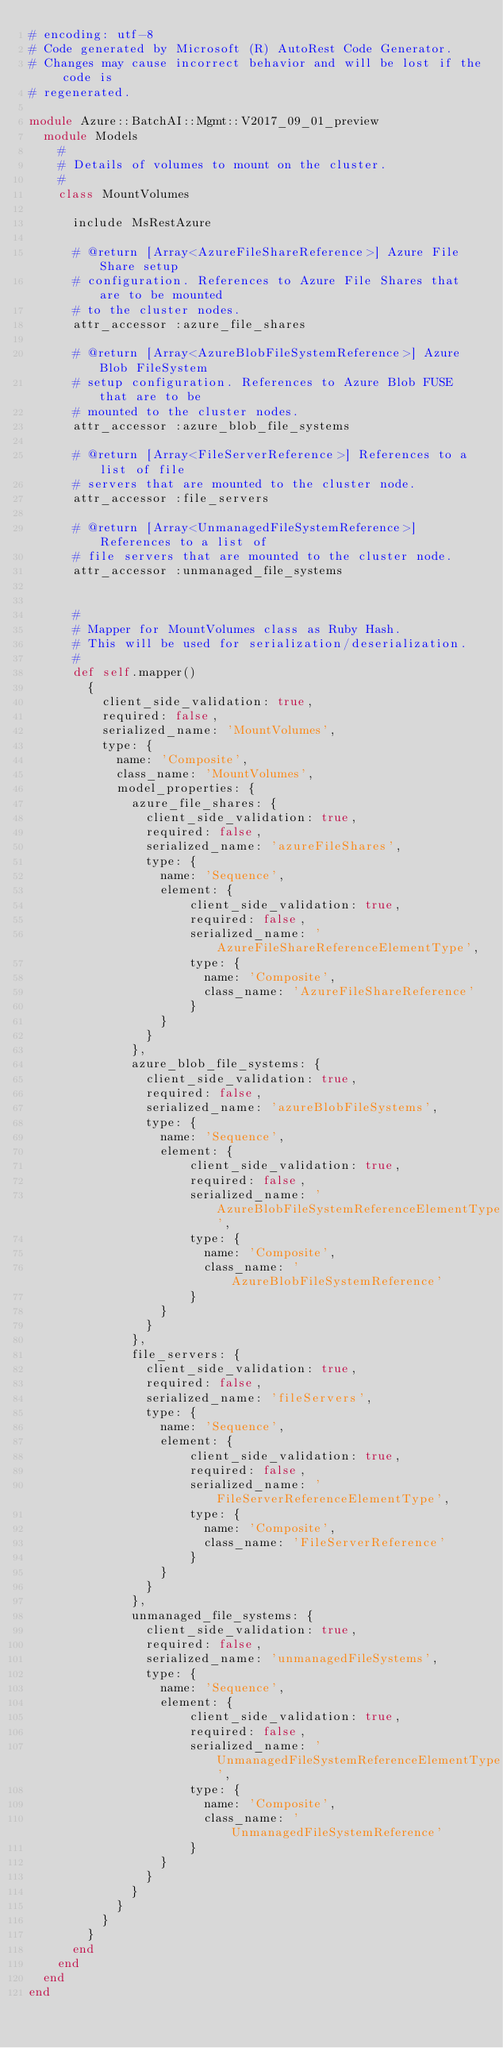<code> <loc_0><loc_0><loc_500><loc_500><_Ruby_># encoding: utf-8
# Code generated by Microsoft (R) AutoRest Code Generator.
# Changes may cause incorrect behavior and will be lost if the code is
# regenerated.

module Azure::BatchAI::Mgmt::V2017_09_01_preview
  module Models
    #
    # Details of volumes to mount on the cluster.
    #
    class MountVolumes

      include MsRestAzure

      # @return [Array<AzureFileShareReference>] Azure File Share setup
      # configuration. References to Azure File Shares that are to be mounted
      # to the cluster nodes.
      attr_accessor :azure_file_shares

      # @return [Array<AzureBlobFileSystemReference>] Azure Blob FileSystem
      # setup configuration. References to Azure Blob FUSE that are to be
      # mounted to the cluster nodes.
      attr_accessor :azure_blob_file_systems

      # @return [Array<FileServerReference>] References to a list of file
      # servers that are mounted to the cluster node.
      attr_accessor :file_servers

      # @return [Array<UnmanagedFileSystemReference>] References to a list of
      # file servers that are mounted to the cluster node.
      attr_accessor :unmanaged_file_systems


      #
      # Mapper for MountVolumes class as Ruby Hash.
      # This will be used for serialization/deserialization.
      #
      def self.mapper()
        {
          client_side_validation: true,
          required: false,
          serialized_name: 'MountVolumes',
          type: {
            name: 'Composite',
            class_name: 'MountVolumes',
            model_properties: {
              azure_file_shares: {
                client_side_validation: true,
                required: false,
                serialized_name: 'azureFileShares',
                type: {
                  name: 'Sequence',
                  element: {
                      client_side_validation: true,
                      required: false,
                      serialized_name: 'AzureFileShareReferenceElementType',
                      type: {
                        name: 'Composite',
                        class_name: 'AzureFileShareReference'
                      }
                  }
                }
              },
              azure_blob_file_systems: {
                client_side_validation: true,
                required: false,
                serialized_name: 'azureBlobFileSystems',
                type: {
                  name: 'Sequence',
                  element: {
                      client_side_validation: true,
                      required: false,
                      serialized_name: 'AzureBlobFileSystemReferenceElementType',
                      type: {
                        name: 'Composite',
                        class_name: 'AzureBlobFileSystemReference'
                      }
                  }
                }
              },
              file_servers: {
                client_side_validation: true,
                required: false,
                serialized_name: 'fileServers',
                type: {
                  name: 'Sequence',
                  element: {
                      client_side_validation: true,
                      required: false,
                      serialized_name: 'FileServerReferenceElementType',
                      type: {
                        name: 'Composite',
                        class_name: 'FileServerReference'
                      }
                  }
                }
              },
              unmanaged_file_systems: {
                client_side_validation: true,
                required: false,
                serialized_name: 'unmanagedFileSystems',
                type: {
                  name: 'Sequence',
                  element: {
                      client_side_validation: true,
                      required: false,
                      serialized_name: 'UnmanagedFileSystemReferenceElementType',
                      type: {
                        name: 'Composite',
                        class_name: 'UnmanagedFileSystemReference'
                      }
                  }
                }
              }
            }
          }
        }
      end
    end
  end
end
</code> 